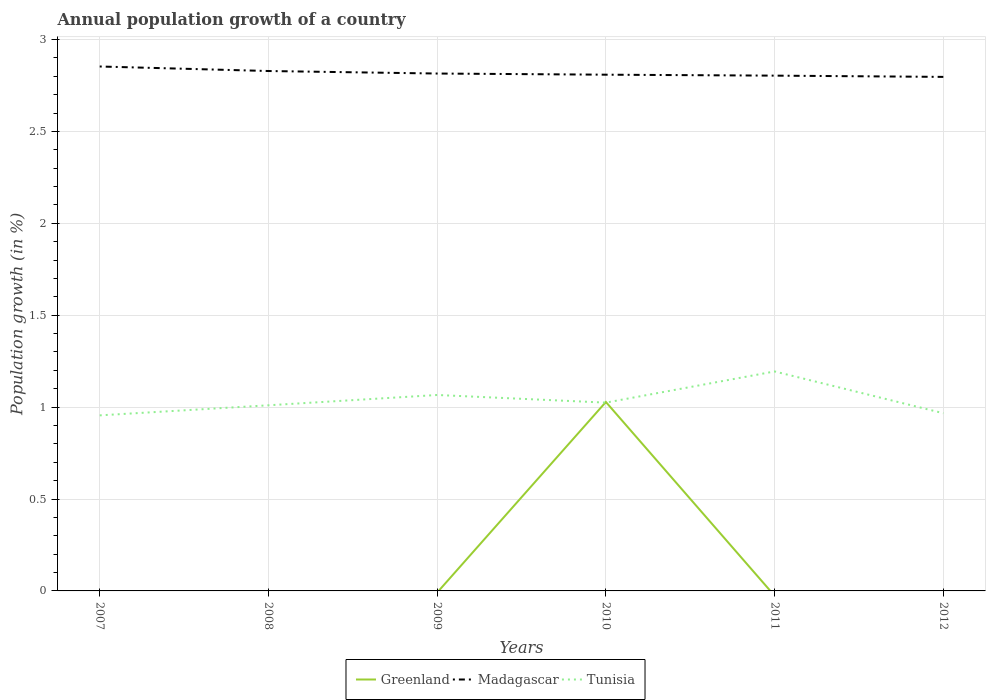Is the number of lines equal to the number of legend labels?
Provide a short and direct response. No. What is the total annual population growth in Madagascar in the graph?
Your answer should be compact. 0.06. What is the difference between the highest and the second highest annual population growth in Greenland?
Keep it short and to the point. 1.03. How many years are there in the graph?
Provide a short and direct response. 6. What is the difference between two consecutive major ticks on the Y-axis?
Offer a very short reply. 0.5. Does the graph contain grids?
Provide a succinct answer. Yes. Where does the legend appear in the graph?
Your answer should be very brief. Bottom center. What is the title of the graph?
Make the answer very short. Annual population growth of a country. Does "Australia" appear as one of the legend labels in the graph?
Your answer should be very brief. No. What is the label or title of the X-axis?
Provide a short and direct response. Years. What is the label or title of the Y-axis?
Your answer should be very brief. Population growth (in %). What is the Population growth (in %) in Madagascar in 2007?
Offer a terse response. 2.85. What is the Population growth (in %) of Tunisia in 2007?
Keep it short and to the point. 0.96. What is the Population growth (in %) in Greenland in 2008?
Offer a terse response. 0. What is the Population growth (in %) of Madagascar in 2008?
Offer a very short reply. 2.83. What is the Population growth (in %) of Tunisia in 2008?
Make the answer very short. 1.01. What is the Population growth (in %) in Madagascar in 2009?
Provide a short and direct response. 2.81. What is the Population growth (in %) in Tunisia in 2009?
Provide a short and direct response. 1.07. What is the Population growth (in %) in Greenland in 2010?
Give a very brief answer. 1.03. What is the Population growth (in %) of Madagascar in 2010?
Offer a very short reply. 2.81. What is the Population growth (in %) of Tunisia in 2010?
Provide a succinct answer. 1.02. What is the Population growth (in %) in Greenland in 2011?
Give a very brief answer. 0. What is the Population growth (in %) in Madagascar in 2011?
Make the answer very short. 2.8. What is the Population growth (in %) of Tunisia in 2011?
Your answer should be very brief. 1.19. What is the Population growth (in %) of Greenland in 2012?
Your answer should be compact. 0. What is the Population growth (in %) of Madagascar in 2012?
Offer a very short reply. 2.8. What is the Population growth (in %) in Tunisia in 2012?
Your answer should be very brief. 0.97. Across all years, what is the maximum Population growth (in %) of Greenland?
Ensure brevity in your answer.  1.03. Across all years, what is the maximum Population growth (in %) in Madagascar?
Give a very brief answer. 2.85. Across all years, what is the maximum Population growth (in %) of Tunisia?
Make the answer very short. 1.19. Across all years, what is the minimum Population growth (in %) in Madagascar?
Offer a very short reply. 2.8. Across all years, what is the minimum Population growth (in %) in Tunisia?
Your response must be concise. 0.96. What is the total Population growth (in %) in Greenland in the graph?
Provide a succinct answer. 1.03. What is the total Population growth (in %) of Madagascar in the graph?
Ensure brevity in your answer.  16.91. What is the total Population growth (in %) in Tunisia in the graph?
Keep it short and to the point. 6.22. What is the difference between the Population growth (in %) of Madagascar in 2007 and that in 2008?
Make the answer very short. 0.02. What is the difference between the Population growth (in %) in Tunisia in 2007 and that in 2008?
Provide a succinct answer. -0.05. What is the difference between the Population growth (in %) in Madagascar in 2007 and that in 2009?
Offer a very short reply. 0.04. What is the difference between the Population growth (in %) in Tunisia in 2007 and that in 2009?
Provide a succinct answer. -0.11. What is the difference between the Population growth (in %) of Madagascar in 2007 and that in 2010?
Offer a terse response. 0.04. What is the difference between the Population growth (in %) of Tunisia in 2007 and that in 2010?
Give a very brief answer. -0.07. What is the difference between the Population growth (in %) of Madagascar in 2007 and that in 2011?
Give a very brief answer. 0.05. What is the difference between the Population growth (in %) of Tunisia in 2007 and that in 2011?
Give a very brief answer. -0.24. What is the difference between the Population growth (in %) in Madagascar in 2007 and that in 2012?
Offer a very short reply. 0.06. What is the difference between the Population growth (in %) in Tunisia in 2007 and that in 2012?
Give a very brief answer. -0.01. What is the difference between the Population growth (in %) in Madagascar in 2008 and that in 2009?
Provide a succinct answer. 0.01. What is the difference between the Population growth (in %) in Tunisia in 2008 and that in 2009?
Make the answer very short. -0.06. What is the difference between the Population growth (in %) in Tunisia in 2008 and that in 2010?
Give a very brief answer. -0.01. What is the difference between the Population growth (in %) of Madagascar in 2008 and that in 2011?
Offer a very short reply. 0.03. What is the difference between the Population growth (in %) in Tunisia in 2008 and that in 2011?
Provide a short and direct response. -0.18. What is the difference between the Population growth (in %) in Madagascar in 2008 and that in 2012?
Provide a short and direct response. 0.03. What is the difference between the Population growth (in %) in Tunisia in 2008 and that in 2012?
Give a very brief answer. 0.04. What is the difference between the Population growth (in %) of Madagascar in 2009 and that in 2010?
Make the answer very short. 0.01. What is the difference between the Population growth (in %) of Tunisia in 2009 and that in 2010?
Ensure brevity in your answer.  0.04. What is the difference between the Population growth (in %) in Madagascar in 2009 and that in 2011?
Offer a very short reply. 0.01. What is the difference between the Population growth (in %) in Tunisia in 2009 and that in 2011?
Your answer should be compact. -0.13. What is the difference between the Population growth (in %) of Madagascar in 2009 and that in 2012?
Provide a short and direct response. 0.02. What is the difference between the Population growth (in %) of Tunisia in 2009 and that in 2012?
Offer a terse response. 0.1. What is the difference between the Population growth (in %) in Madagascar in 2010 and that in 2011?
Provide a succinct answer. 0.01. What is the difference between the Population growth (in %) in Tunisia in 2010 and that in 2011?
Offer a terse response. -0.17. What is the difference between the Population growth (in %) in Madagascar in 2010 and that in 2012?
Give a very brief answer. 0.01. What is the difference between the Population growth (in %) of Tunisia in 2010 and that in 2012?
Offer a very short reply. 0.06. What is the difference between the Population growth (in %) in Madagascar in 2011 and that in 2012?
Give a very brief answer. 0.01. What is the difference between the Population growth (in %) of Tunisia in 2011 and that in 2012?
Provide a succinct answer. 0.23. What is the difference between the Population growth (in %) of Madagascar in 2007 and the Population growth (in %) of Tunisia in 2008?
Ensure brevity in your answer.  1.84. What is the difference between the Population growth (in %) in Madagascar in 2007 and the Population growth (in %) in Tunisia in 2009?
Make the answer very short. 1.79. What is the difference between the Population growth (in %) of Madagascar in 2007 and the Population growth (in %) of Tunisia in 2010?
Provide a short and direct response. 1.83. What is the difference between the Population growth (in %) in Madagascar in 2007 and the Population growth (in %) in Tunisia in 2011?
Provide a succinct answer. 1.66. What is the difference between the Population growth (in %) of Madagascar in 2007 and the Population growth (in %) of Tunisia in 2012?
Offer a terse response. 1.89. What is the difference between the Population growth (in %) in Madagascar in 2008 and the Population growth (in %) in Tunisia in 2009?
Make the answer very short. 1.76. What is the difference between the Population growth (in %) in Madagascar in 2008 and the Population growth (in %) in Tunisia in 2010?
Provide a succinct answer. 1.8. What is the difference between the Population growth (in %) in Madagascar in 2008 and the Population growth (in %) in Tunisia in 2011?
Give a very brief answer. 1.63. What is the difference between the Population growth (in %) in Madagascar in 2008 and the Population growth (in %) in Tunisia in 2012?
Your answer should be compact. 1.86. What is the difference between the Population growth (in %) of Madagascar in 2009 and the Population growth (in %) of Tunisia in 2010?
Give a very brief answer. 1.79. What is the difference between the Population growth (in %) of Madagascar in 2009 and the Population growth (in %) of Tunisia in 2011?
Your answer should be very brief. 1.62. What is the difference between the Population growth (in %) of Madagascar in 2009 and the Population growth (in %) of Tunisia in 2012?
Keep it short and to the point. 1.85. What is the difference between the Population growth (in %) of Greenland in 2010 and the Population growth (in %) of Madagascar in 2011?
Ensure brevity in your answer.  -1.78. What is the difference between the Population growth (in %) of Greenland in 2010 and the Population growth (in %) of Tunisia in 2011?
Your response must be concise. -0.17. What is the difference between the Population growth (in %) of Madagascar in 2010 and the Population growth (in %) of Tunisia in 2011?
Keep it short and to the point. 1.61. What is the difference between the Population growth (in %) in Greenland in 2010 and the Population growth (in %) in Madagascar in 2012?
Provide a short and direct response. -1.77. What is the difference between the Population growth (in %) in Greenland in 2010 and the Population growth (in %) in Tunisia in 2012?
Provide a succinct answer. 0.06. What is the difference between the Population growth (in %) of Madagascar in 2010 and the Population growth (in %) of Tunisia in 2012?
Your response must be concise. 1.84. What is the difference between the Population growth (in %) of Madagascar in 2011 and the Population growth (in %) of Tunisia in 2012?
Make the answer very short. 1.84. What is the average Population growth (in %) of Greenland per year?
Provide a succinct answer. 0.17. What is the average Population growth (in %) of Madagascar per year?
Ensure brevity in your answer.  2.82. What is the average Population growth (in %) in Tunisia per year?
Your response must be concise. 1.04. In the year 2007, what is the difference between the Population growth (in %) of Madagascar and Population growth (in %) of Tunisia?
Offer a terse response. 1.9. In the year 2008, what is the difference between the Population growth (in %) in Madagascar and Population growth (in %) in Tunisia?
Your response must be concise. 1.82. In the year 2009, what is the difference between the Population growth (in %) of Madagascar and Population growth (in %) of Tunisia?
Make the answer very short. 1.75. In the year 2010, what is the difference between the Population growth (in %) in Greenland and Population growth (in %) in Madagascar?
Provide a short and direct response. -1.78. In the year 2010, what is the difference between the Population growth (in %) in Greenland and Population growth (in %) in Tunisia?
Make the answer very short. 0. In the year 2010, what is the difference between the Population growth (in %) of Madagascar and Population growth (in %) of Tunisia?
Provide a succinct answer. 1.78. In the year 2011, what is the difference between the Population growth (in %) of Madagascar and Population growth (in %) of Tunisia?
Your answer should be very brief. 1.61. In the year 2012, what is the difference between the Population growth (in %) in Madagascar and Population growth (in %) in Tunisia?
Make the answer very short. 1.83. What is the ratio of the Population growth (in %) of Madagascar in 2007 to that in 2008?
Your answer should be compact. 1.01. What is the ratio of the Population growth (in %) of Tunisia in 2007 to that in 2008?
Ensure brevity in your answer.  0.95. What is the ratio of the Population growth (in %) in Madagascar in 2007 to that in 2009?
Provide a succinct answer. 1.01. What is the ratio of the Population growth (in %) of Tunisia in 2007 to that in 2009?
Make the answer very short. 0.9. What is the ratio of the Population growth (in %) of Madagascar in 2007 to that in 2010?
Keep it short and to the point. 1.02. What is the ratio of the Population growth (in %) of Tunisia in 2007 to that in 2010?
Give a very brief answer. 0.93. What is the ratio of the Population growth (in %) in Madagascar in 2007 to that in 2011?
Offer a terse response. 1.02. What is the ratio of the Population growth (in %) of Tunisia in 2007 to that in 2011?
Offer a very short reply. 0.8. What is the ratio of the Population growth (in %) of Madagascar in 2007 to that in 2012?
Give a very brief answer. 1.02. What is the ratio of the Population growth (in %) in Tunisia in 2007 to that in 2012?
Offer a very short reply. 0.99. What is the ratio of the Population growth (in %) in Tunisia in 2008 to that in 2009?
Keep it short and to the point. 0.95. What is the ratio of the Population growth (in %) of Madagascar in 2008 to that in 2010?
Offer a terse response. 1.01. What is the ratio of the Population growth (in %) of Tunisia in 2008 to that in 2010?
Your answer should be very brief. 0.99. What is the ratio of the Population growth (in %) in Tunisia in 2008 to that in 2011?
Give a very brief answer. 0.85. What is the ratio of the Population growth (in %) in Madagascar in 2008 to that in 2012?
Provide a short and direct response. 1.01. What is the ratio of the Population growth (in %) in Tunisia in 2008 to that in 2012?
Offer a terse response. 1.04. What is the ratio of the Population growth (in %) in Madagascar in 2009 to that in 2010?
Provide a short and direct response. 1. What is the ratio of the Population growth (in %) of Tunisia in 2009 to that in 2010?
Your answer should be compact. 1.04. What is the ratio of the Population growth (in %) of Madagascar in 2009 to that in 2011?
Your answer should be very brief. 1. What is the ratio of the Population growth (in %) in Tunisia in 2009 to that in 2011?
Make the answer very short. 0.89. What is the ratio of the Population growth (in %) of Madagascar in 2009 to that in 2012?
Make the answer very short. 1.01. What is the ratio of the Population growth (in %) of Tunisia in 2009 to that in 2012?
Provide a short and direct response. 1.1. What is the ratio of the Population growth (in %) of Tunisia in 2010 to that in 2011?
Your answer should be very brief. 0.86. What is the ratio of the Population growth (in %) of Tunisia in 2010 to that in 2012?
Give a very brief answer. 1.06. What is the ratio of the Population growth (in %) of Tunisia in 2011 to that in 2012?
Offer a terse response. 1.24. What is the difference between the highest and the second highest Population growth (in %) in Madagascar?
Ensure brevity in your answer.  0.02. What is the difference between the highest and the second highest Population growth (in %) of Tunisia?
Keep it short and to the point. 0.13. What is the difference between the highest and the lowest Population growth (in %) in Greenland?
Make the answer very short. 1.03. What is the difference between the highest and the lowest Population growth (in %) in Madagascar?
Ensure brevity in your answer.  0.06. What is the difference between the highest and the lowest Population growth (in %) in Tunisia?
Make the answer very short. 0.24. 